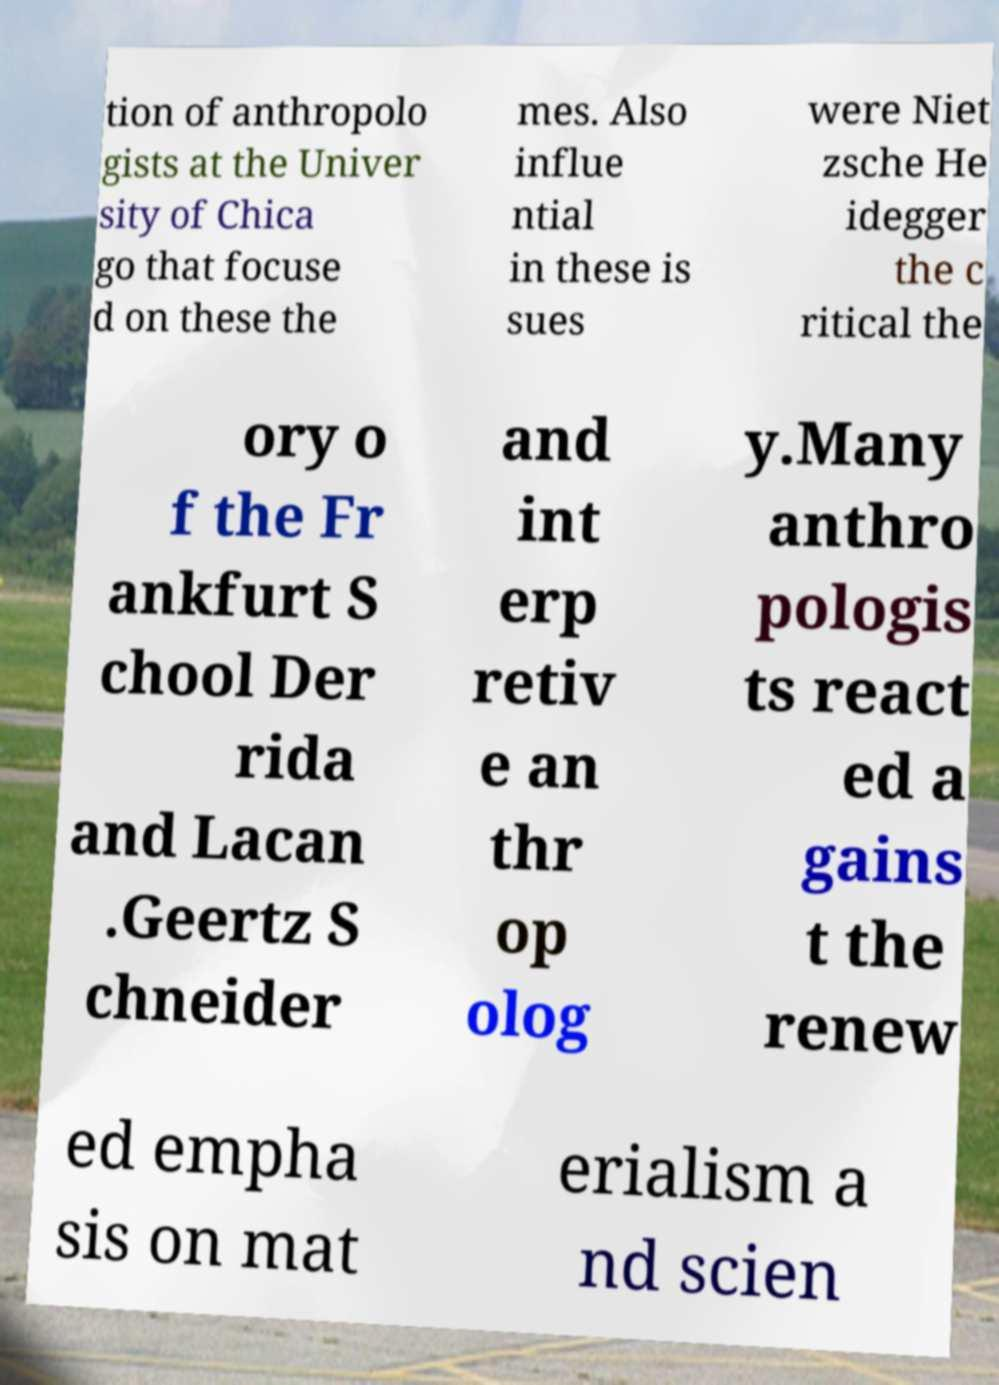Could you assist in decoding the text presented in this image and type it out clearly? tion of anthropolo gists at the Univer sity of Chica go that focuse d on these the mes. Also influe ntial in these is sues were Niet zsche He idegger the c ritical the ory o f the Fr ankfurt S chool Der rida and Lacan .Geertz S chneider and int erp retiv e an thr op olog y.Many anthro pologis ts react ed a gains t the renew ed empha sis on mat erialism a nd scien 